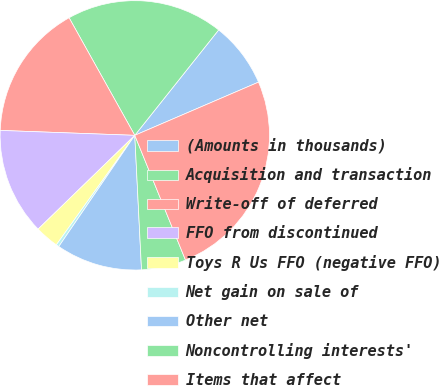Convert chart to OTSL. <chart><loc_0><loc_0><loc_500><loc_500><pie_chart><fcel>(Amounts in thousands)<fcel>Acquisition and transaction<fcel>Write-off of deferred<fcel>FFO from discontinued<fcel>Toys R Us FFO (negative FFO)<fcel>Net gain on sale of<fcel>Other net<fcel>Noncontrolling interests'<fcel>Items that affect<nl><fcel>7.84%<fcel>18.81%<fcel>16.31%<fcel>12.84%<fcel>2.85%<fcel>0.35%<fcel>10.34%<fcel>5.35%<fcel>25.32%<nl></chart> 